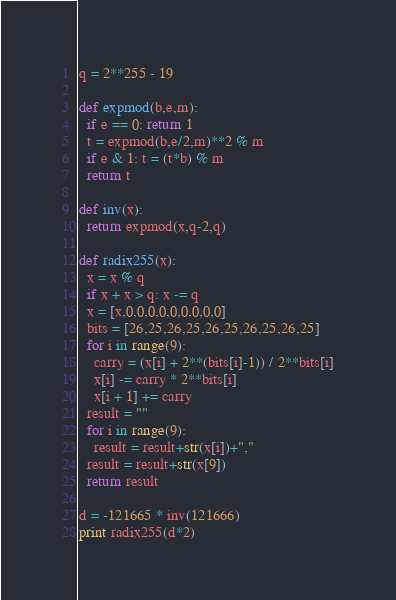<code> <loc_0><loc_0><loc_500><loc_500><_Python_>q = 2**255 - 19

def expmod(b,e,m):
  if e == 0: return 1
  t = expmod(b,e/2,m)**2 % m
  if e & 1: t = (t*b) % m
  return t

def inv(x):
  return expmod(x,q-2,q)

def radix255(x):
  x = x % q
  if x + x > q: x -= q
  x = [x,0,0,0,0,0,0,0,0,0]
  bits = [26,25,26,25,26,25,26,25,26,25]
  for i in range(9):
    carry = (x[i] + 2**(bits[i]-1)) / 2**bits[i]
    x[i] -= carry * 2**bits[i]
    x[i + 1] += carry
  result = ""
  for i in range(9):
    result = result+str(x[i])+","
  result = result+str(x[9])
  return result

d = -121665 * inv(121666)
print radix255(d*2)
</code> 